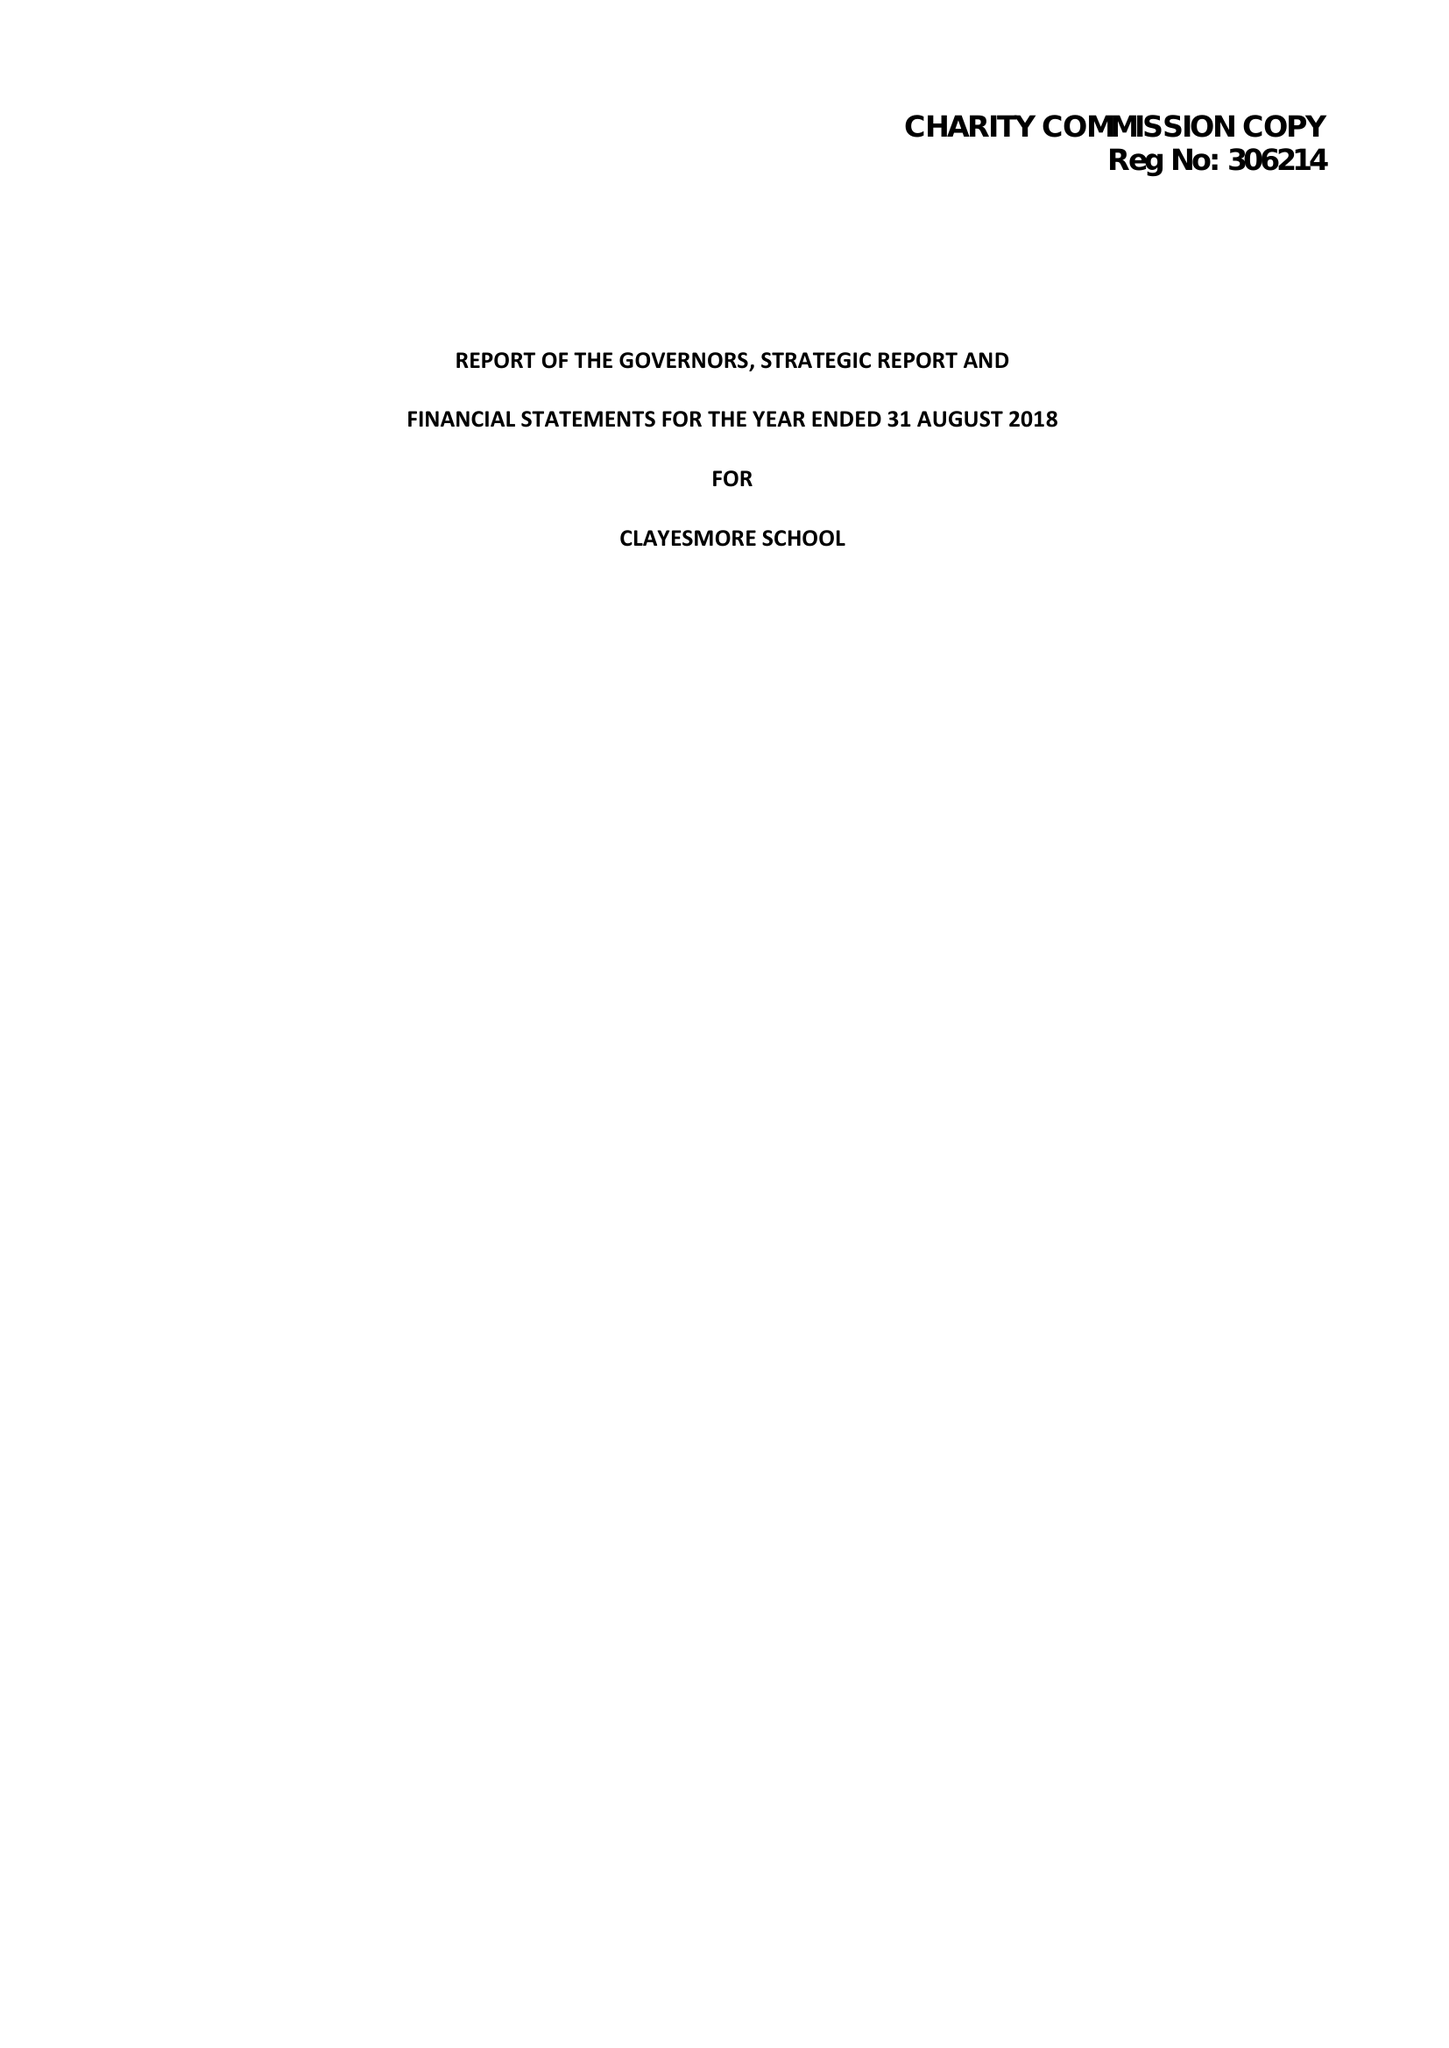What is the value for the address__street_line?
Answer the question using a single word or phrase. None 